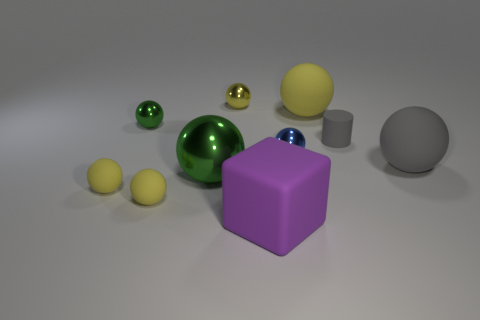How many large things are both on the right side of the matte cylinder and in front of the large green metallic ball? There are no large objects that meet both conditions of being on the right side of the matte cylinder and in front of the large green metallic ball. All large objects are either on one side or do not meet the other specified condition. 